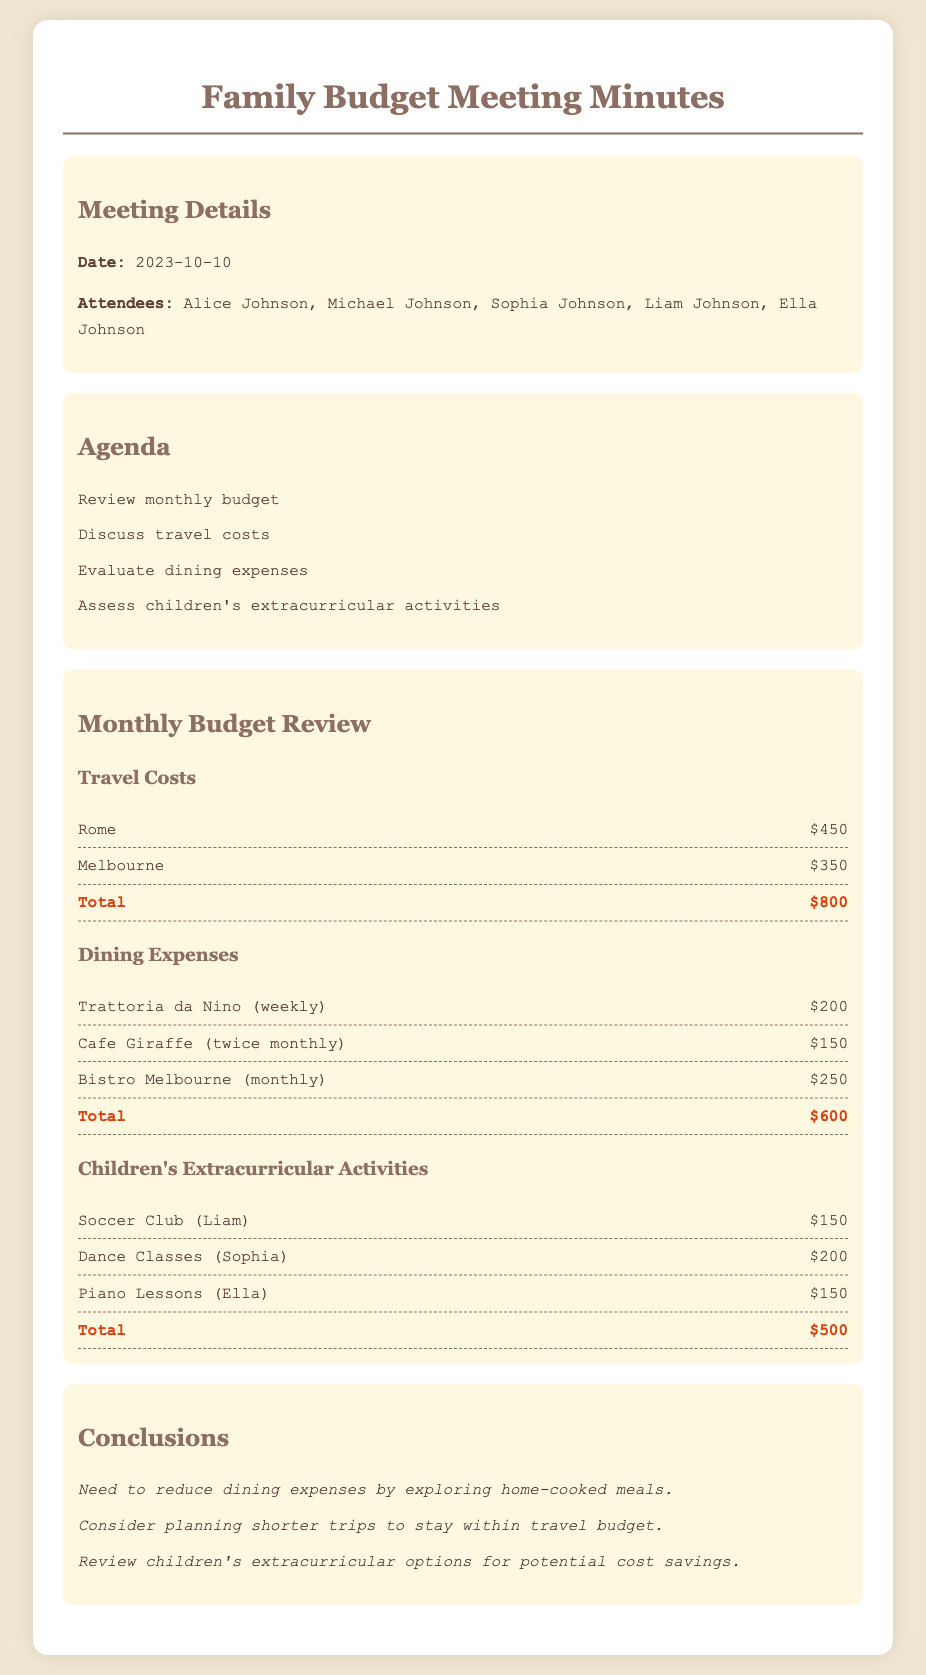what was the date of the meeting? The date of the meeting is stated clearly in the meeting details section.
Answer: 2023-10-10 who attended the meeting? The attendees are listed in the meeting details section.
Answer: Alice Johnson, Michael Johnson, Sophia Johnson, Liam Johnson, Ella Johnson what was the total travel cost? The total travel cost is calculated from the individual travel expenses listed in the document.
Answer: $800 how much did the family spend on dining expenses? The total dining expenses are provided at the end of the dining section.
Answer: $600 which child's activity has the highest expense? The highest expense is indicated by comparing the individual extracurricular activities listed.
Answer: Dance Classes (Sophia) what is one suggestion made in the conclusions? The conclusions provide recommendations based on the review, focusing on budget management.
Answer: Reduce dining expenses by exploring home-cooked meals how many times do they visit Cafe Giraffe? The frequency of visits to Cafe Giraffe is mentioned in the dining expenses section.
Answer: twice monthly what is the total cost for children's extracurricular activities? The total is derived from the listed expenses in the children's extracurricular activities section.
Answer: $500 